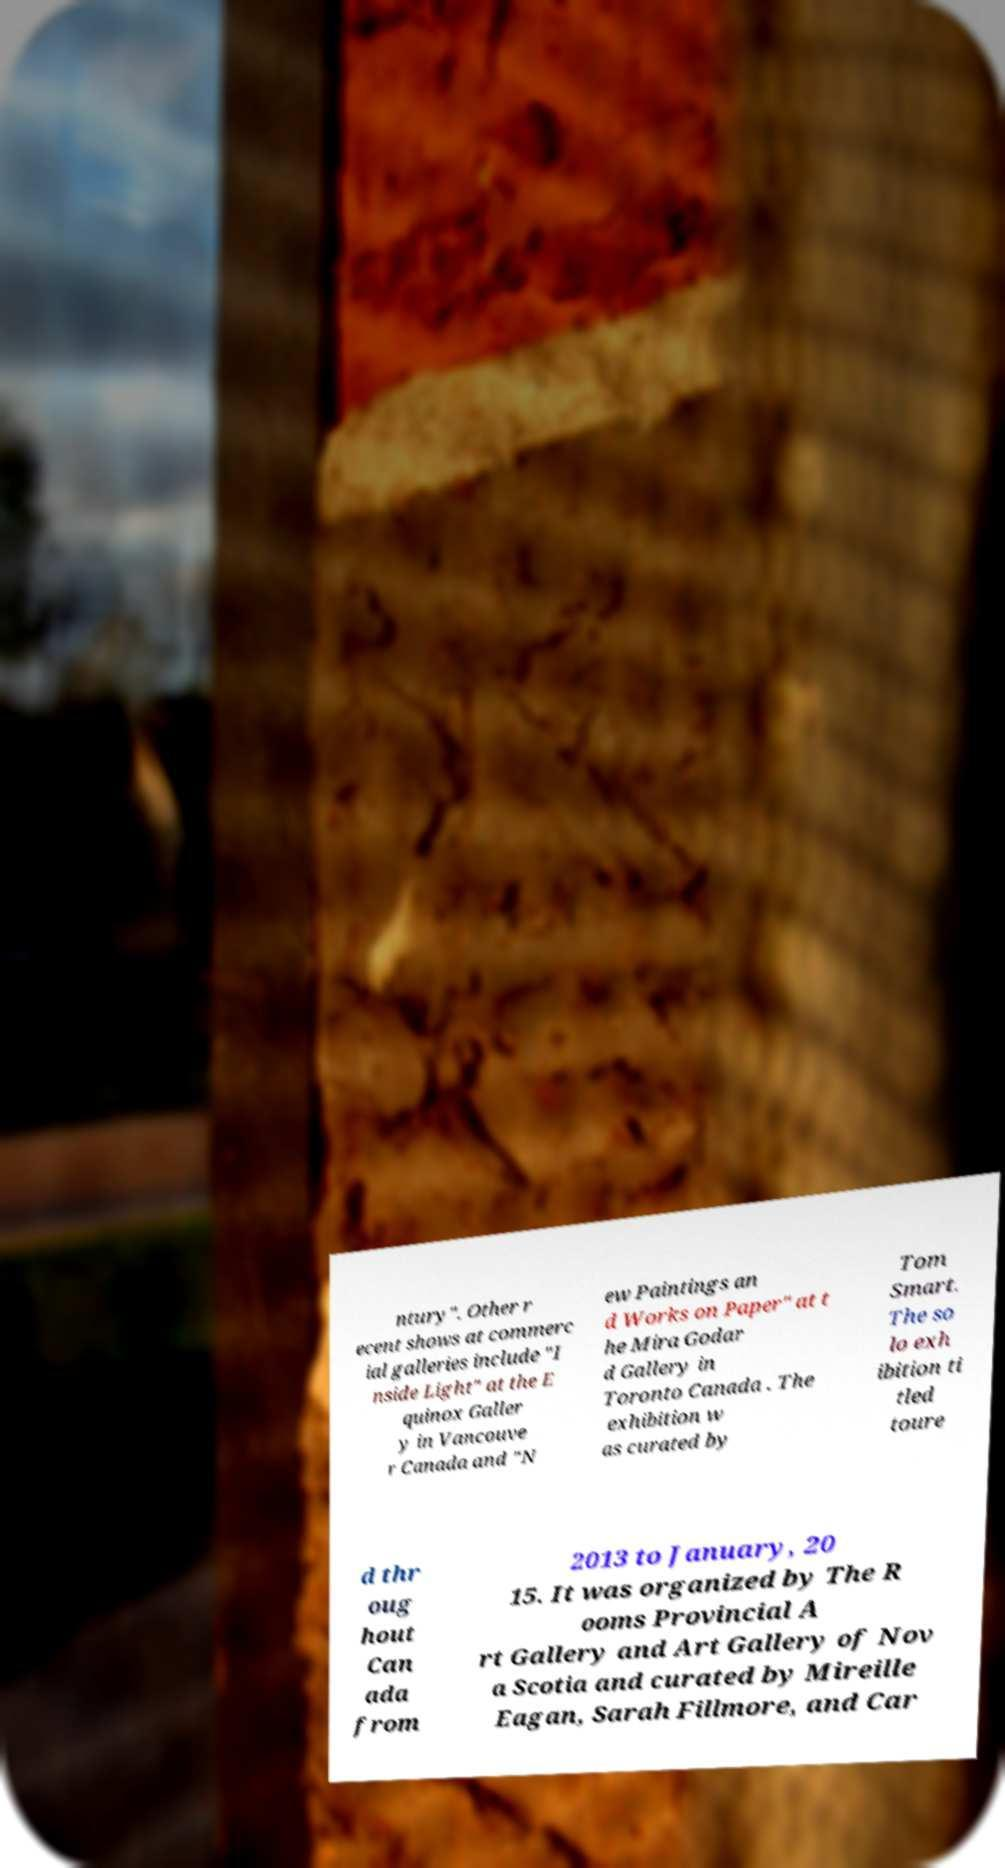Can you accurately transcribe the text from the provided image for me? ntury". Other r ecent shows at commerc ial galleries include "I nside Light" at the E quinox Galler y in Vancouve r Canada and "N ew Paintings an d Works on Paper" at t he Mira Godar d Gallery in Toronto Canada . The exhibition w as curated by Tom Smart. The so lo exh ibition ti tled toure d thr oug hout Can ada from 2013 to January, 20 15. It was organized by The R ooms Provincial A rt Gallery and Art Gallery of Nov a Scotia and curated by Mireille Eagan, Sarah Fillmore, and Car 